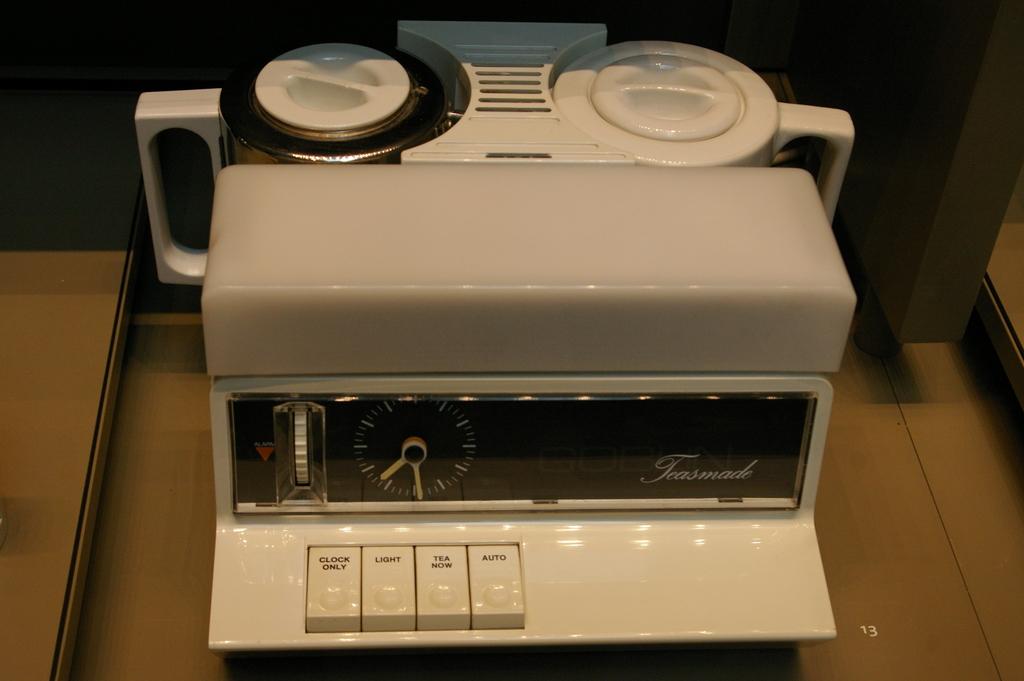What is this machine?
Make the answer very short. Teasmade. What is the brand of this machine?
Give a very brief answer. Teasmade. 